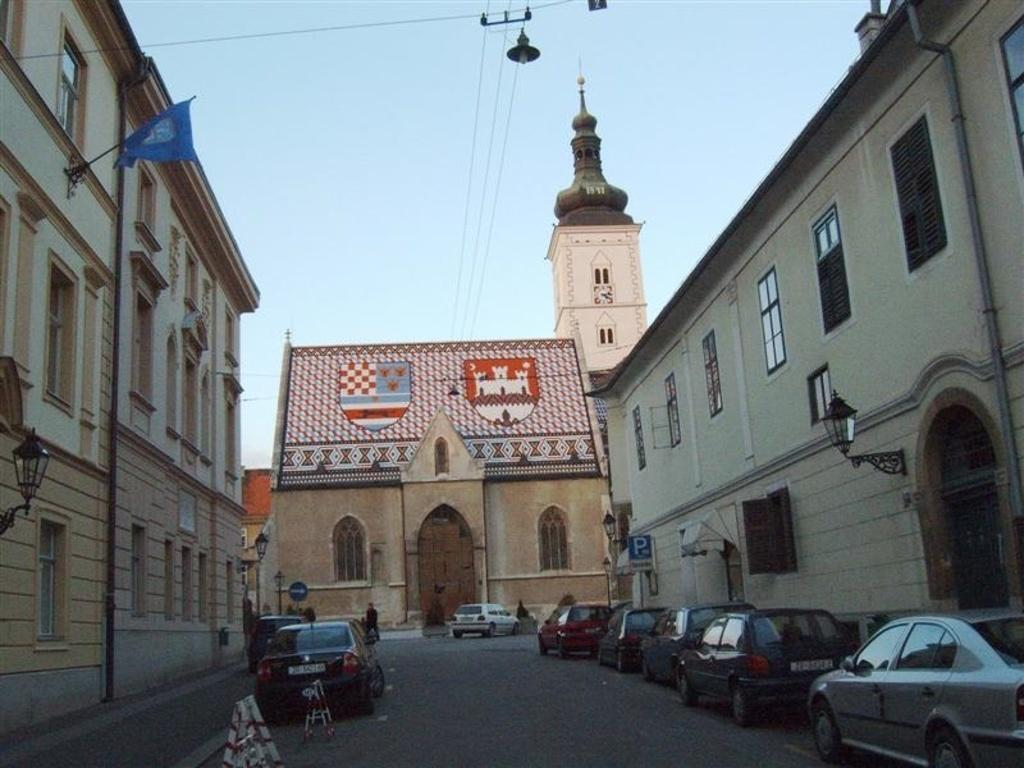What is the main feature of the image? There is a road in the image. What is happening on the road? There are cars on the road. What else can be seen in the image besides the road and cars? There are buildings, wires, lights, sign boards, and a blue color flag visible in the image. What is the background of the image? The sky is visible in the background of the image. What type of bomb can be seen in the image? There is no bomb present in the image. What kind of teeth can be seen on the buildings in the image? Buildings do not have teeth, so this question cannot be answered. 